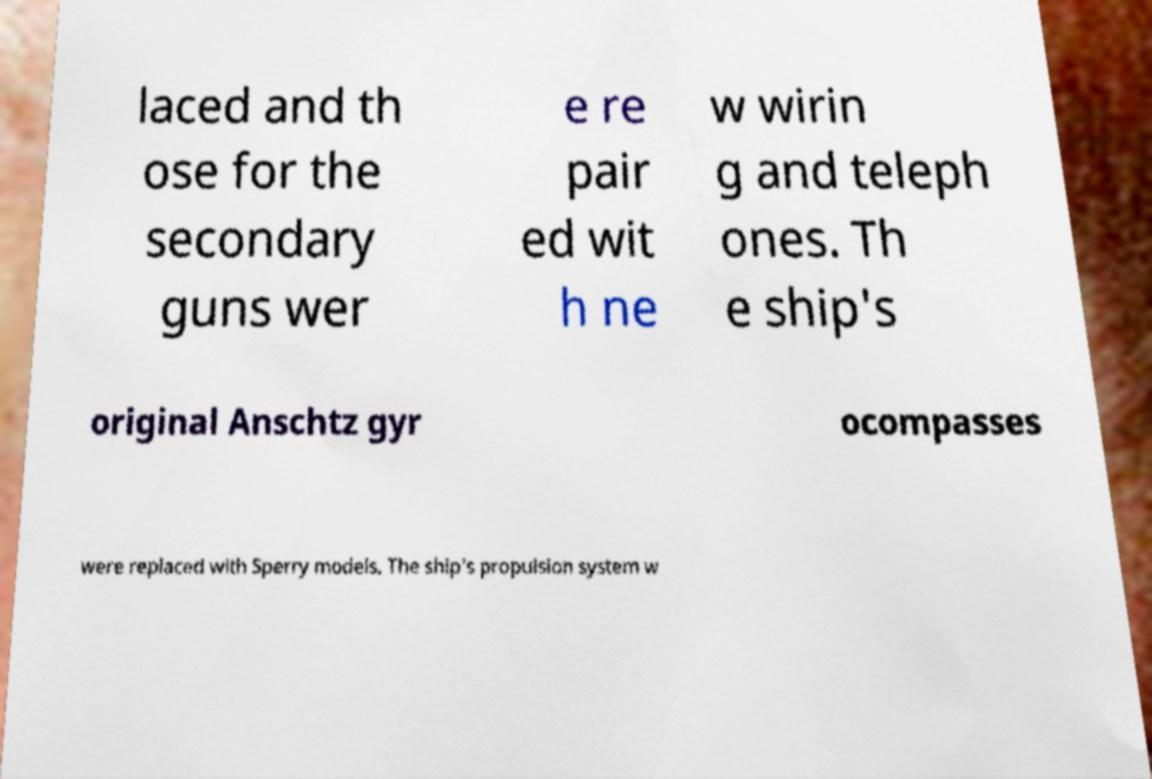Can you read and provide the text displayed in the image?This photo seems to have some interesting text. Can you extract and type it out for me? laced and th ose for the secondary guns wer e re pair ed wit h ne w wirin g and teleph ones. Th e ship's original Anschtz gyr ocompasses were replaced with Sperry models. The ship's propulsion system w 